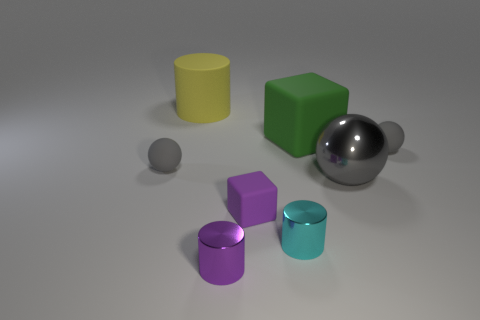Does the large metal object behind the purple matte block have the same color as the sphere that is on the left side of the small purple metal object?
Offer a terse response. Yes. How many objects are either tiny gray objects left of the big matte cube or large things behind the big gray shiny object?
Provide a succinct answer. 3. What is the sphere in front of the tiny gray matte thing that is on the left side of the small gray ball on the right side of the large yellow matte cylinder made of?
Provide a succinct answer. Metal. There is a tiny matte ball that is on the left side of the tiny cube; does it have the same color as the large metal object?
Your answer should be very brief. Yes. The small thing that is both behind the large gray ball and left of the tiny rubber block is made of what material?
Your response must be concise. Rubber. Are there any yellow cylinders of the same size as the yellow object?
Your answer should be compact. No. What number of big green matte blocks are there?
Make the answer very short. 1. How many small matte things are on the right side of the large green thing?
Provide a short and direct response. 1. Is the material of the green cube the same as the purple block?
Keep it short and to the point. Yes. How many things are in front of the small block and to the left of the big yellow rubber cylinder?
Your answer should be compact. 0. 